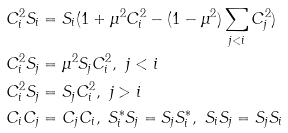Convert formula to latex. <formula><loc_0><loc_0><loc_500><loc_500>C _ { i } ^ { 2 } S _ { i } & = S _ { i } ( 1 + \mu ^ { 2 } C _ { i } ^ { 2 } - ( 1 - \mu ^ { 2 } ) \sum _ { j < i } C _ { j } ^ { 2 } ) \\ C _ { i } ^ { 2 } S _ { j } & = \mu ^ { 2 } S _ { j } C _ { i } ^ { 2 } , \ j < i \\ C _ { i } ^ { 2 } S _ { j } & = S _ { j } C _ { i } ^ { 2 } , \ j > i \\ C _ { i } C _ { j } & = C _ { j } C _ { i } , \ S _ { i } ^ { * } S _ { j } = S _ { j } S _ { i } ^ { * } , \ S _ { i } S _ { j } = S _ { j } S _ { i }</formula> 